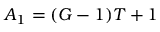Convert formula to latex. <formula><loc_0><loc_0><loc_500><loc_500>A _ { 1 } = ( G - 1 ) T + 1</formula> 